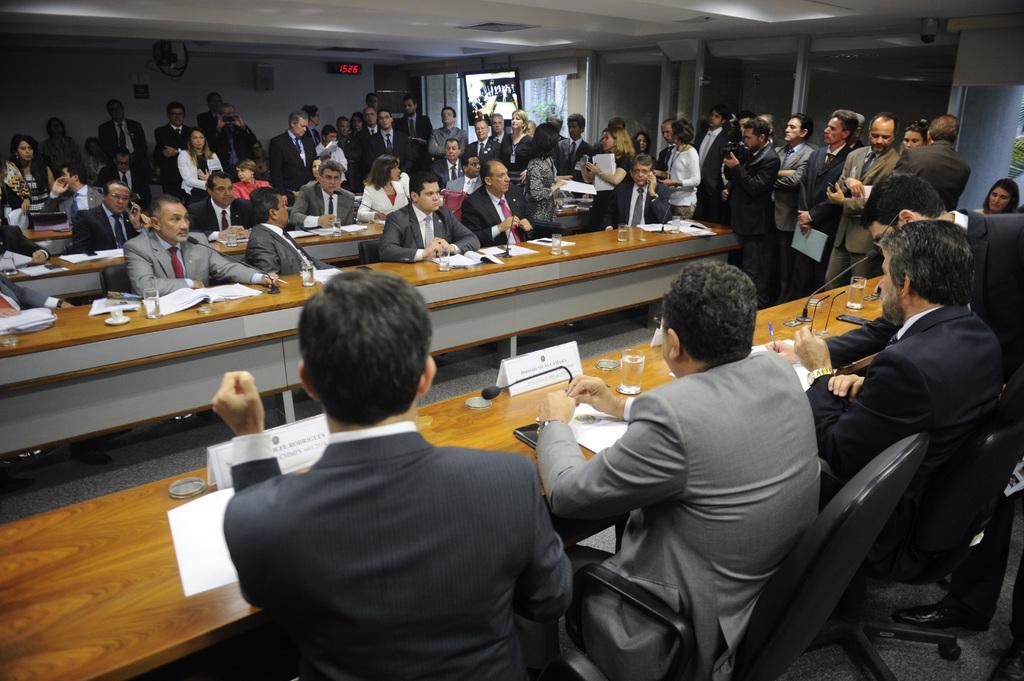Could you give a brief overview of what you see in this image? Here there are group of people sitting and standing and there is a meeting going on here these people are sitting on chairs with microphones on the table in front of them 